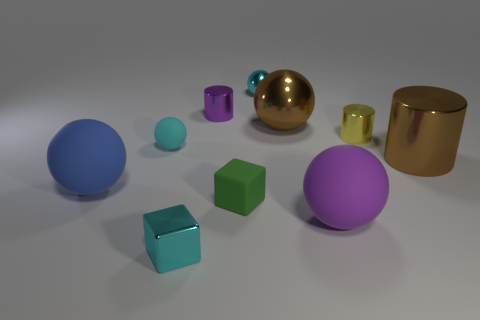How many other things are there of the same color as the rubber block?
Give a very brief answer. 0. Are the big brown cylinder and the tiny yellow object made of the same material?
Ensure brevity in your answer.  Yes. Is there anything else that is the same size as the purple ball?
Offer a terse response. Yes. How many small cubes are right of the big cylinder?
Make the answer very short. 0. The cyan metallic object that is behind the blue thing to the left of the large metallic ball is what shape?
Provide a short and direct response. Sphere. Is there anything else that is the same shape as the purple rubber thing?
Give a very brief answer. Yes. Is the number of cyan metal blocks on the right side of the big purple thing greater than the number of small rubber things?
Offer a terse response. No. What number of cylinders are to the left of the brown metallic thing in front of the brown metallic ball?
Give a very brief answer. 2. There is a shiny object that is behind the cylinder to the left of the tiny cylinder right of the big purple object; what is its shape?
Make the answer very short. Sphere. The blue rubber sphere is what size?
Provide a short and direct response. Large. 